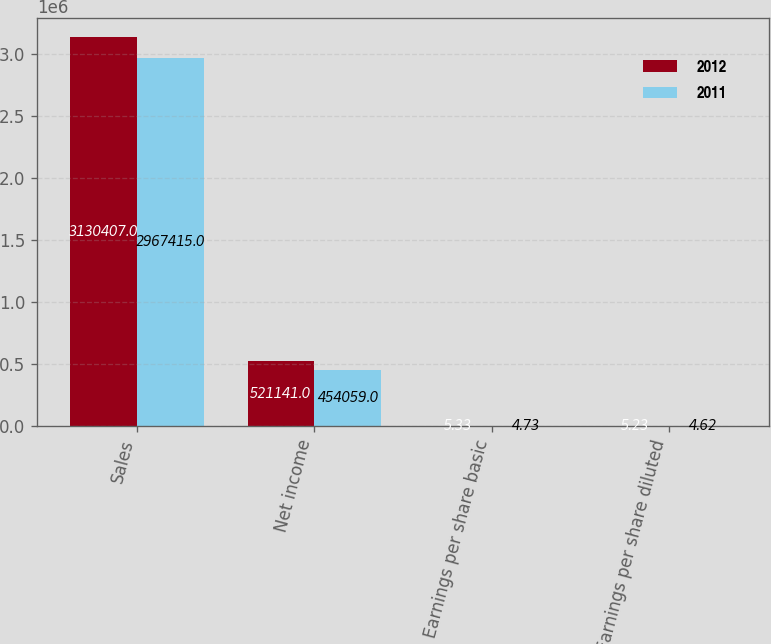Convert chart. <chart><loc_0><loc_0><loc_500><loc_500><stacked_bar_chart><ecel><fcel>Sales<fcel>Net income<fcel>Earnings per share basic<fcel>Earnings per share diluted<nl><fcel>2012<fcel>3.13041e+06<fcel>521141<fcel>5.33<fcel>5.23<nl><fcel>2011<fcel>2.96742e+06<fcel>454059<fcel>4.73<fcel>4.62<nl></chart> 